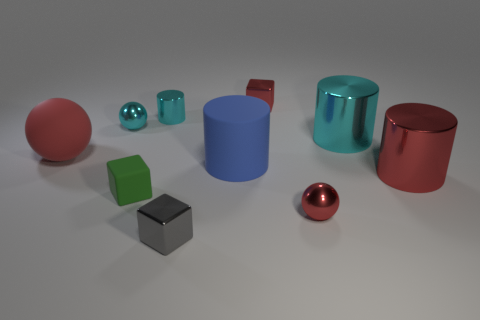How does the lighting affect the appearance of the objects in this scene? The lighting in the scene creates soft shadows on the ground and gives the objects a gentle highlight. This illuminates the objects' colors vividly and accentuates their shiny textures. The lighting appears to be coming from above, as indicated by the positioning of the shadows and the reflections on the objects, which contributes to the three-dimensional feel of the arrangement. 